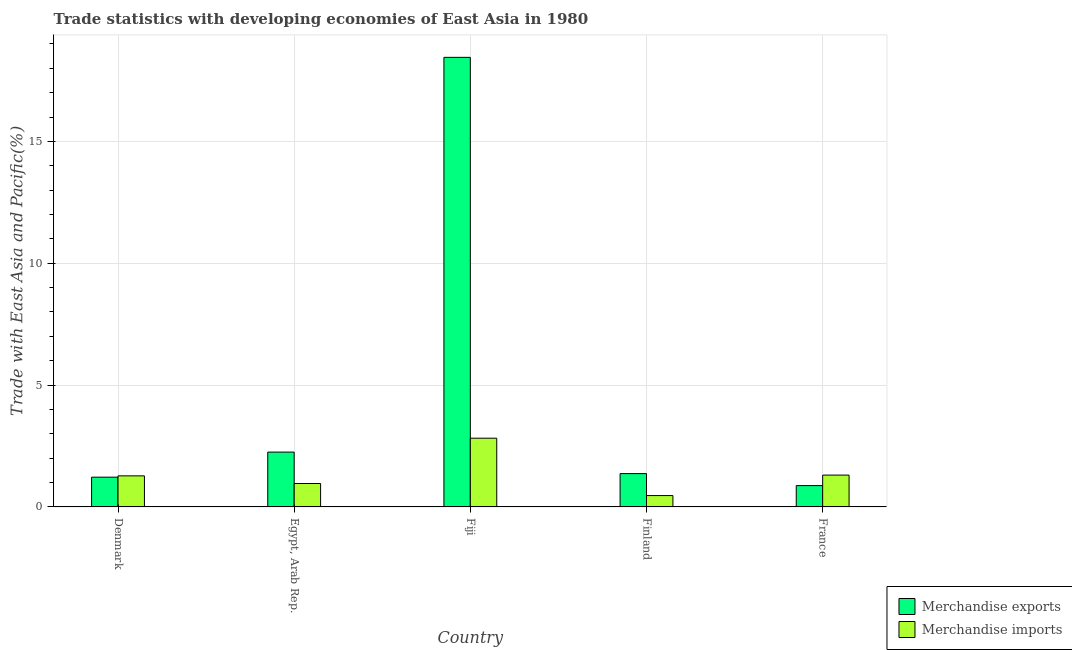How many groups of bars are there?
Your answer should be compact. 5. Are the number of bars per tick equal to the number of legend labels?
Keep it short and to the point. Yes. Are the number of bars on each tick of the X-axis equal?
Provide a short and direct response. Yes. What is the label of the 2nd group of bars from the left?
Offer a terse response. Egypt, Arab Rep. In how many cases, is the number of bars for a given country not equal to the number of legend labels?
Provide a succinct answer. 0. What is the merchandise exports in Finland?
Keep it short and to the point. 1.37. Across all countries, what is the maximum merchandise exports?
Your response must be concise. 18.45. Across all countries, what is the minimum merchandise imports?
Provide a succinct answer. 0.47. In which country was the merchandise imports maximum?
Provide a short and direct response. Fiji. What is the total merchandise imports in the graph?
Your response must be concise. 6.83. What is the difference between the merchandise exports in Denmark and that in Egypt, Arab Rep.?
Provide a succinct answer. -1.03. What is the difference between the merchandise imports in France and the merchandise exports in Finland?
Provide a short and direct response. -0.06. What is the average merchandise exports per country?
Make the answer very short. 4.83. What is the difference between the merchandise imports and merchandise exports in Finland?
Offer a very short reply. -0.9. What is the ratio of the merchandise exports in Fiji to that in France?
Keep it short and to the point. 21.08. What is the difference between the highest and the second highest merchandise imports?
Keep it short and to the point. 1.51. What is the difference between the highest and the lowest merchandise imports?
Ensure brevity in your answer.  2.35. What does the 1st bar from the right in Finland represents?
Provide a succinct answer. Merchandise imports. What is the difference between two consecutive major ticks on the Y-axis?
Offer a very short reply. 5. Where does the legend appear in the graph?
Provide a succinct answer. Bottom right. How are the legend labels stacked?
Provide a short and direct response. Vertical. What is the title of the graph?
Make the answer very short. Trade statistics with developing economies of East Asia in 1980. Does "Primary school" appear as one of the legend labels in the graph?
Offer a very short reply. No. What is the label or title of the X-axis?
Offer a very short reply. Country. What is the label or title of the Y-axis?
Provide a short and direct response. Trade with East Asia and Pacific(%). What is the Trade with East Asia and Pacific(%) of Merchandise exports in Denmark?
Ensure brevity in your answer.  1.22. What is the Trade with East Asia and Pacific(%) of Merchandise imports in Denmark?
Offer a very short reply. 1.28. What is the Trade with East Asia and Pacific(%) in Merchandise exports in Egypt, Arab Rep.?
Offer a very short reply. 2.25. What is the Trade with East Asia and Pacific(%) in Merchandise imports in Egypt, Arab Rep.?
Provide a succinct answer. 0.96. What is the Trade with East Asia and Pacific(%) of Merchandise exports in Fiji?
Your answer should be compact. 18.45. What is the Trade with East Asia and Pacific(%) in Merchandise imports in Fiji?
Offer a very short reply. 2.82. What is the Trade with East Asia and Pacific(%) of Merchandise exports in Finland?
Make the answer very short. 1.37. What is the Trade with East Asia and Pacific(%) of Merchandise imports in Finland?
Offer a very short reply. 0.47. What is the Trade with East Asia and Pacific(%) in Merchandise exports in France?
Provide a succinct answer. 0.88. What is the Trade with East Asia and Pacific(%) of Merchandise imports in France?
Provide a succinct answer. 1.31. Across all countries, what is the maximum Trade with East Asia and Pacific(%) of Merchandise exports?
Give a very brief answer. 18.45. Across all countries, what is the maximum Trade with East Asia and Pacific(%) in Merchandise imports?
Ensure brevity in your answer.  2.82. Across all countries, what is the minimum Trade with East Asia and Pacific(%) in Merchandise exports?
Provide a succinct answer. 0.88. Across all countries, what is the minimum Trade with East Asia and Pacific(%) of Merchandise imports?
Give a very brief answer. 0.47. What is the total Trade with East Asia and Pacific(%) of Merchandise exports in the graph?
Provide a succinct answer. 24.16. What is the total Trade with East Asia and Pacific(%) in Merchandise imports in the graph?
Your answer should be compact. 6.83. What is the difference between the Trade with East Asia and Pacific(%) in Merchandise exports in Denmark and that in Egypt, Arab Rep.?
Provide a short and direct response. -1.03. What is the difference between the Trade with East Asia and Pacific(%) in Merchandise imports in Denmark and that in Egypt, Arab Rep.?
Keep it short and to the point. 0.31. What is the difference between the Trade with East Asia and Pacific(%) in Merchandise exports in Denmark and that in Fiji?
Provide a short and direct response. -17.23. What is the difference between the Trade with East Asia and Pacific(%) in Merchandise imports in Denmark and that in Fiji?
Your response must be concise. -1.55. What is the difference between the Trade with East Asia and Pacific(%) of Merchandise exports in Denmark and that in Finland?
Offer a terse response. -0.15. What is the difference between the Trade with East Asia and Pacific(%) in Merchandise imports in Denmark and that in Finland?
Your answer should be very brief. 0.81. What is the difference between the Trade with East Asia and Pacific(%) in Merchandise exports in Denmark and that in France?
Ensure brevity in your answer.  0.35. What is the difference between the Trade with East Asia and Pacific(%) in Merchandise imports in Denmark and that in France?
Give a very brief answer. -0.03. What is the difference between the Trade with East Asia and Pacific(%) of Merchandise exports in Egypt, Arab Rep. and that in Fiji?
Your response must be concise. -16.2. What is the difference between the Trade with East Asia and Pacific(%) in Merchandise imports in Egypt, Arab Rep. and that in Fiji?
Ensure brevity in your answer.  -1.86. What is the difference between the Trade with East Asia and Pacific(%) in Merchandise exports in Egypt, Arab Rep. and that in Finland?
Your answer should be compact. 0.88. What is the difference between the Trade with East Asia and Pacific(%) in Merchandise imports in Egypt, Arab Rep. and that in Finland?
Your answer should be very brief. 0.49. What is the difference between the Trade with East Asia and Pacific(%) in Merchandise exports in Egypt, Arab Rep. and that in France?
Make the answer very short. 1.38. What is the difference between the Trade with East Asia and Pacific(%) in Merchandise imports in Egypt, Arab Rep. and that in France?
Your answer should be very brief. -0.35. What is the difference between the Trade with East Asia and Pacific(%) of Merchandise exports in Fiji and that in Finland?
Your answer should be compact. 17.08. What is the difference between the Trade with East Asia and Pacific(%) of Merchandise imports in Fiji and that in Finland?
Give a very brief answer. 2.35. What is the difference between the Trade with East Asia and Pacific(%) of Merchandise exports in Fiji and that in France?
Give a very brief answer. 17.57. What is the difference between the Trade with East Asia and Pacific(%) in Merchandise imports in Fiji and that in France?
Offer a very short reply. 1.51. What is the difference between the Trade with East Asia and Pacific(%) of Merchandise exports in Finland and that in France?
Make the answer very short. 0.49. What is the difference between the Trade with East Asia and Pacific(%) of Merchandise imports in Finland and that in France?
Provide a short and direct response. -0.84. What is the difference between the Trade with East Asia and Pacific(%) of Merchandise exports in Denmark and the Trade with East Asia and Pacific(%) of Merchandise imports in Egypt, Arab Rep.?
Your answer should be compact. 0.26. What is the difference between the Trade with East Asia and Pacific(%) of Merchandise exports in Denmark and the Trade with East Asia and Pacific(%) of Merchandise imports in Fiji?
Keep it short and to the point. -1.6. What is the difference between the Trade with East Asia and Pacific(%) in Merchandise exports in Denmark and the Trade with East Asia and Pacific(%) in Merchandise imports in Finland?
Offer a very short reply. 0.76. What is the difference between the Trade with East Asia and Pacific(%) of Merchandise exports in Denmark and the Trade with East Asia and Pacific(%) of Merchandise imports in France?
Give a very brief answer. -0.09. What is the difference between the Trade with East Asia and Pacific(%) in Merchandise exports in Egypt, Arab Rep. and the Trade with East Asia and Pacific(%) in Merchandise imports in Fiji?
Give a very brief answer. -0.57. What is the difference between the Trade with East Asia and Pacific(%) of Merchandise exports in Egypt, Arab Rep. and the Trade with East Asia and Pacific(%) of Merchandise imports in Finland?
Provide a short and direct response. 1.78. What is the difference between the Trade with East Asia and Pacific(%) in Merchandise exports in Egypt, Arab Rep. and the Trade with East Asia and Pacific(%) in Merchandise imports in France?
Make the answer very short. 0.94. What is the difference between the Trade with East Asia and Pacific(%) in Merchandise exports in Fiji and the Trade with East Asia and Pacific(%) in Merchandise imports in Finland?
Keep it short and to the point. 17.98. What is the difference between the Trade with East Asia and Pacific(%) in Merchandise exports in Fiji and the Trade with East Asia and Pacific(%) in Merchandise imports in France?
Ensure brevity in your answer.  17.14. What is the difference between the Trade with East Asia and Pacific(%) of Merchandise exports in Finland and the Trade with East Asia and Pacific(%) of Merchandise imports in France?
Provide a succinct answer. 0.06. What is the average Trade with East Asia and Pacific(%) in Merchandise exports per country?
Provide a short and direct response. 4.83. What is the average Trade with East Asia and Pacific(%) of Merchandise imports per country?
Keep it short and to the point. 1.37. What is the difference between the Trade with East Asia and Pacific(%) in Merchandise exports and Trade with East Asia and Pacific(%) in Merchandise imports in Denmark?
Your response must be concise. -0.05. What is the difference between the Trade with East Asia and Pacific(%) of Merchandise exports and Trade with East Asia and Pacific(%) of Merchandise imports in Egypt, Arab Rep.?
Your answer should be compact. 1.29. What is the difference between the Trade with East Asia and Pacific(%) in Merchandise exports and Trade with East Asia and Pacific(%) in Merchandise imports in Fiji?
Offer a very short reply. 15.63. What is the difference between the Trade with East Asia and Pacific(%) in Merchandise exports and Trade with East Asia and Pacific(%) in Merchandise imports in Finland?
Provide a short and direct response. 0.9. What is the difference between the Trade with East Asia and Pacific(%) of Merchandise exports and Trade with East Asia and Pacific(%) of Merchandise imports in France?
Make the answer very short. -0.43. What is the ratio of the Trade with East Asia and Pacific(%) in Merchandise exports in Denmark to that in Egypt, Arab Rep.?
Offer a terse response. 0.54. What is the ratio of the Trade with East Asia and Pacific(%) in Merchandise imports in Denmark to that in Egypt, Arab Rep.?
Your answer should be compact. 1.33. What is the ratio of the Trade with East Asia and Pacific(%) of Merchandise exports in Denmark to that in Fiji?
Provide a short and direct response. 0.07. What is the ratio of the Trade with East Asia and Pacific(%) in Merchandise imports in Denmark to that in Fiji?
Your answer should be very brief. 0.45. What is the ratio of the Trade with East Asia and Pacific(%) of Merchandise exports in Denmark to that in Finland?
Keep it short and to the point. 0.89. What is the ratio of the Trade with East Asia and Pacific(%) in Merchandise imports in Denmark to that in Finland?
Your answer should be compact. 2.74. What is the ratio of the Trade with East Asia and Pacific(%) of Merchandise exports in Denmark to that in France?
Your answer should be very brief. 1.4. What is the ratio of the Trade with East Asia and Pacific(%) in Merchandise imports in Denmark to that in France?
Your answer should be very brief. 0.98. What is the ratio of the Trade with East Asia and Pacific(%) of Merchandise exports in Egypt, Arab Rep. to that in Fiji?
Make the answer very short. 0.12. What is the ratio of the Trade with East Asia and Pacific(%) in Merchandise imports in Egypt, Arab Rep. to that in Fiji?
Your answer should be compact. 0.34. What is the ratio of the Trade with East Asia and Pacific(%) of Merchandise exports in Egypt, Arab Rep. to that in Finland?
Your answer should be very brief. 1.65. What is the ratio of the Trade with East Asia and Pacific(%) in Merchandise imports in Egypt, Arab Rep. to that in Finland?
Provide a succinct answer. 2.06. What is the ratio of the Trade with East Asia and Pacific(%) in Merchandise exports in Egypt, Arab Rep. to that in France?
Give a very brief answer. 2.57. What is the ratio of the Trade with East Asia and Pacific(%) of Merchandise imports in Egypt, Arab Rep. to that in France?
Ensure brevity in your answer.  0.74. What is the ratio of the Trade with East Asia and Pacific(%) in Merchandise exports in Fiji to that in Finland?
Offer a very short reply. 13.49. What is the ratio of the Trade with East Asia and Pacific(%) in Merchandise imports in Fiji to that in Finland?
Your answer should be compact. 6.05. What is the ratio of the Trade with East Asia and Pacific(%) in Merchandise exports in Fiji to that in France?
Ensure brevity in your answer.  21.08. What is the ratio of the Trade with East Asia and Pacific(%) of Merchandise imports in Fiji to that in France?
Offer a very short reply. 2.16. What is the ratio of the Trade with East Asia and Pacific(%) in Merchandise exports in Finland to that in France?
Provide a succinct answer. 1.56. What is the ratio of the Trade with East Asia and Pacific(%) in Merchandise imports in Finland to that in France?
Offer a terse response. 0.36. What is the difference between the highest and the second highest Trade with East Asia and Pacific(%) of Merchandise exports?
Keep it short and to the point. 16.2. What is the difference between the highest and the second highest Trade with East Asia and Pacific(%) in Merchandise imports?
Give a very brief answer. 1.51. What is the difference between the highest and the lowest Trade with East Asia and Pacific(%) of Merchandise exports?
Provide a succinct answer. 17.57. What is the difference between the highest and the lowest Trade with East Asia and Pacific(%) in Merchandise imports?
Give a very brief answer. 2.35. 